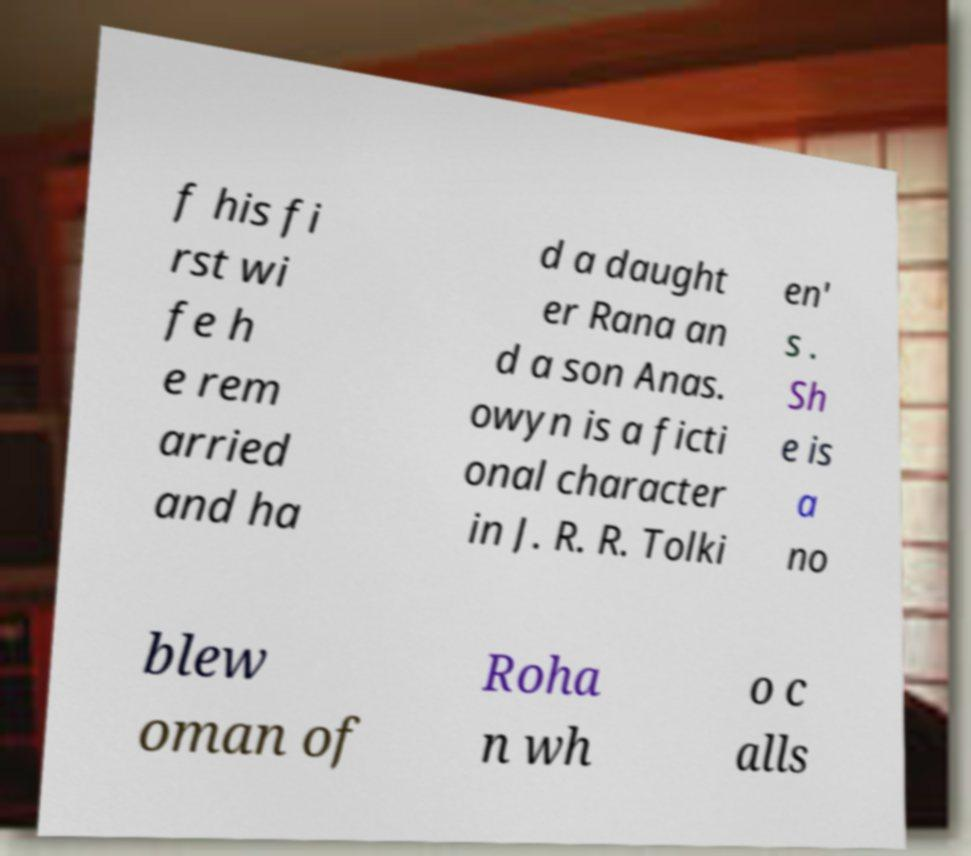For documentation purposes, I need the text within this image transcribed. Could you provide that? f his fi rst wi fe h e rem arried and ha d a daught er Rana an d a son Anas. owyn is a ficti onal character in J. R. R. Tolki en' s . Sh e is a no blew oman of Roha n wh o c alls 